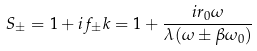<formula> <loc_0><loc_0><loc_500><loc_500>S _ { \pm } = 1 + i f _ { \pm } k = 1 + \frac { i r _ { 0 } \omega } { \lambda ( \omega \pm \beta \omega _ { 0 } ) }</formula> 